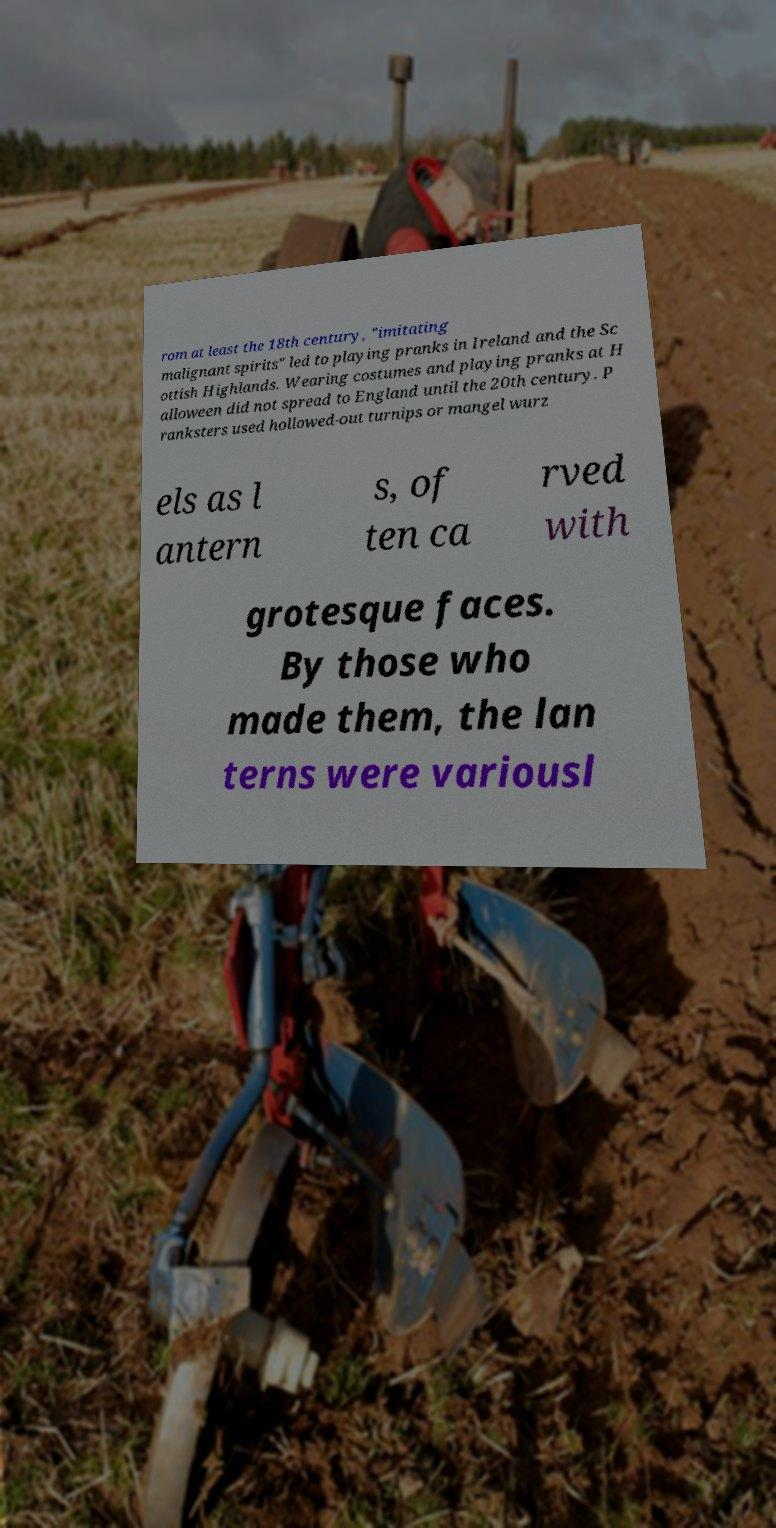Please read and relay the text visible in this image. What does it say? rom at least the 18th century, "imitating malignant spirits" led to playing pranks in Ireland and the Sc ottish Highlands. Wearing costumes and playing pranks at H alloween did not spread to England until the 20th century. P ranksters used hollowed-out turnips or mangel wurz els as l antern s, of ten ca rved with grotesque faces. By those who made them, the lan terns were variousl 